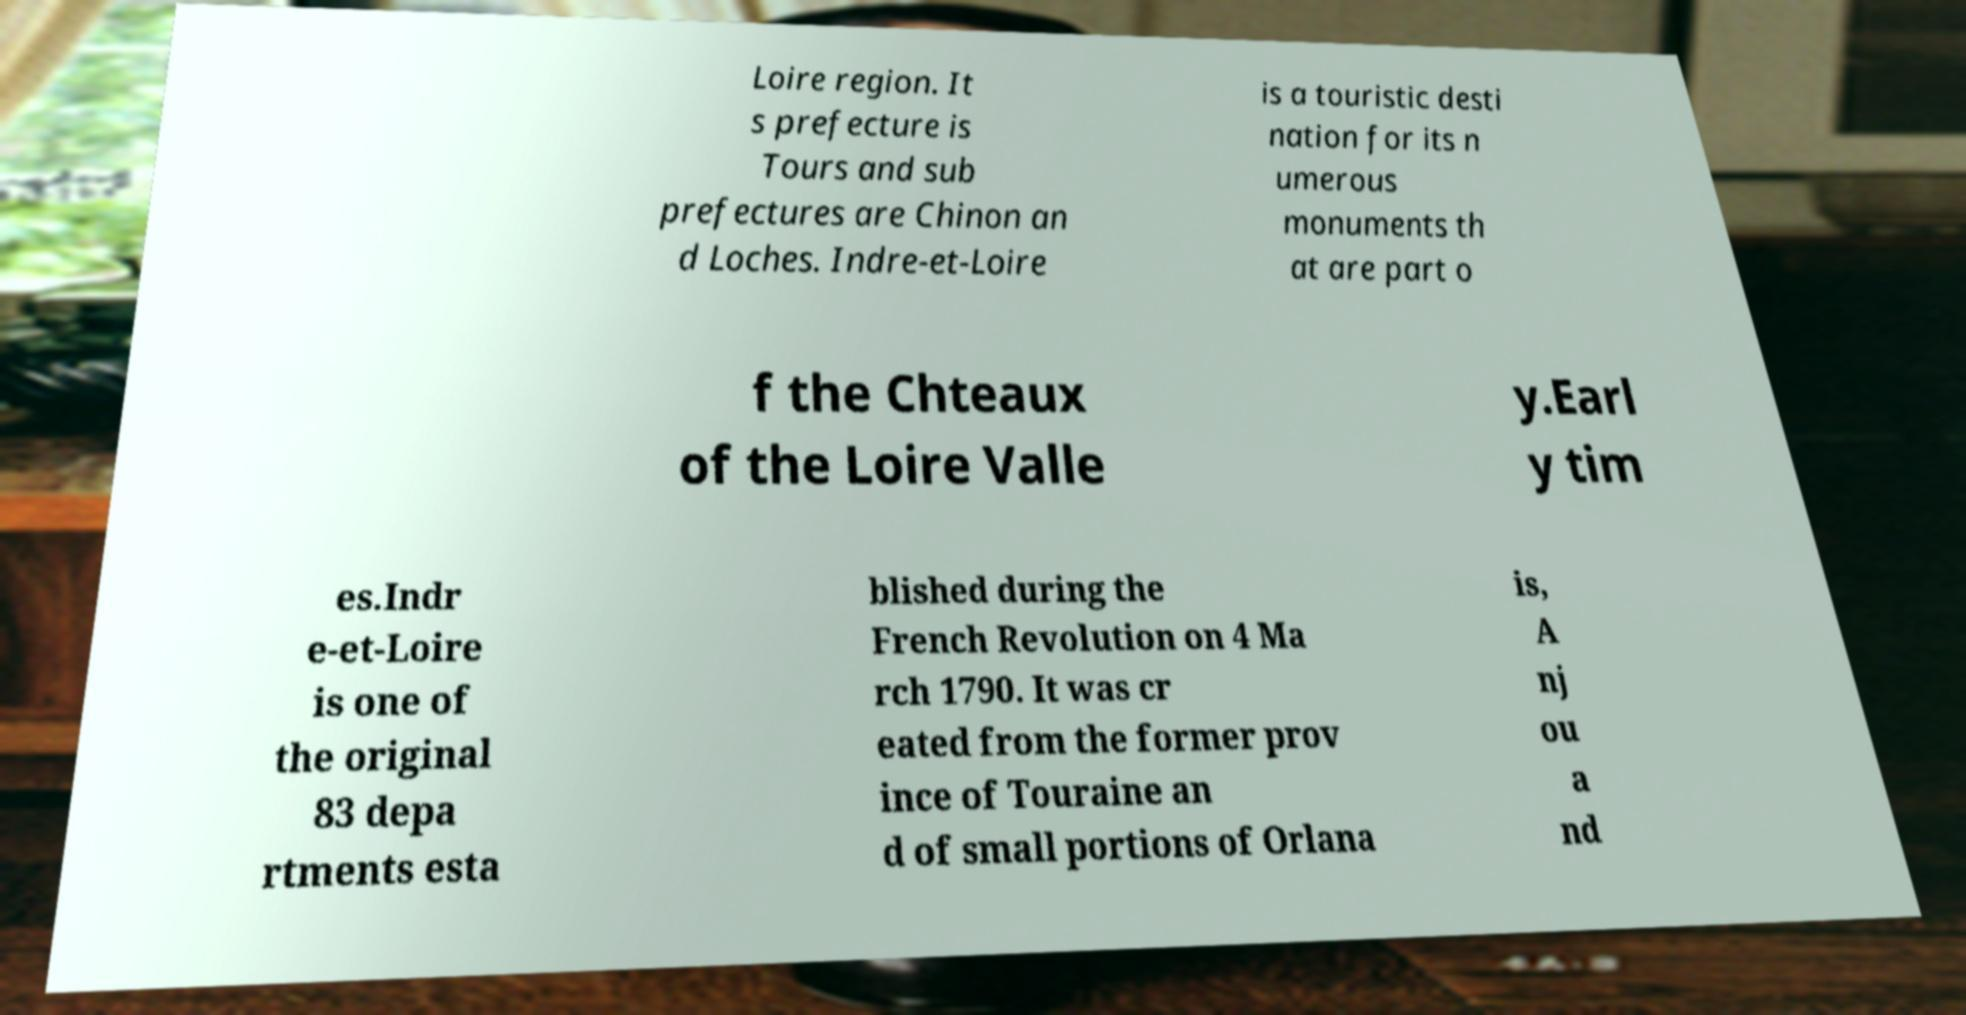Please read and relay the text visible in this image. What does it say? Loire region. It s prefecture is Tours and sub prefectures are Chinon an d Loches. Indre-et-Loire is a touristic desti nation for its n umerous monuments th at are part o f the Chteaux of the Loire Valle y.Earl y tim es.Indr e-et-Loire is one of the original 83 depa rtments esta blished during the French Revolution on 4 Ma rch 1790. It was cr eated from the former prov ince of Touraine an d of small portions of Orlana is, A nj ou a nd 